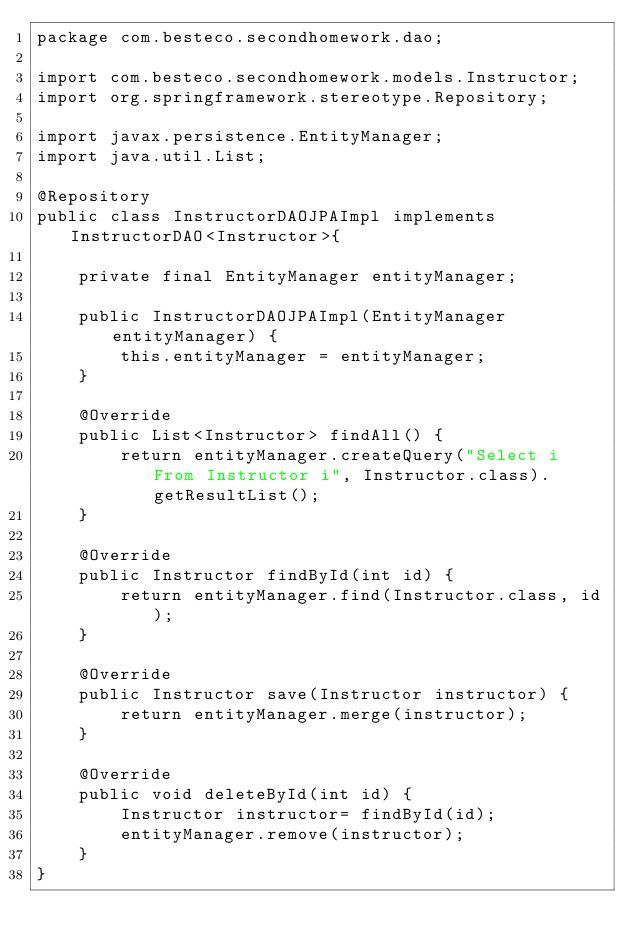<code> <loc_0><loc_0><loc_500><loc_500><_Java_>package com.besteco.secondhomework.dao;

import com.besteco.secondhomework.models.Instructor;
import org.springframework.stereotype.Repository;

import javax.persistence.EntityManager;
import java.util.List;

@Repository
public class InstructorDAOJPAImpl implements InstructorDAO<Instructor>{

    private final EntityManager entityManager;

    public InstructorDAOJPAImpl(EntityManager entityManager) {
        this.entityManager = entityManager;
    }

    @Override
    public List<Instructor> findAll() {
        return entityManager.createQuery("Select i From Instructor i", Instructor.class).getResultList();
    }

    @Override
    public Instructor findById(int id) {
        return entityManager.find(Instructor.class, id);
    }

    @Override
    public Instructor save(Instructor instructor) {
        return entityManager.merge(instructor);
    }

    @Override
    public void deleteById(int id) {
        Instructor instructor= findById(id);
        entityManager.remove(instructor);
    }
}
</code> 